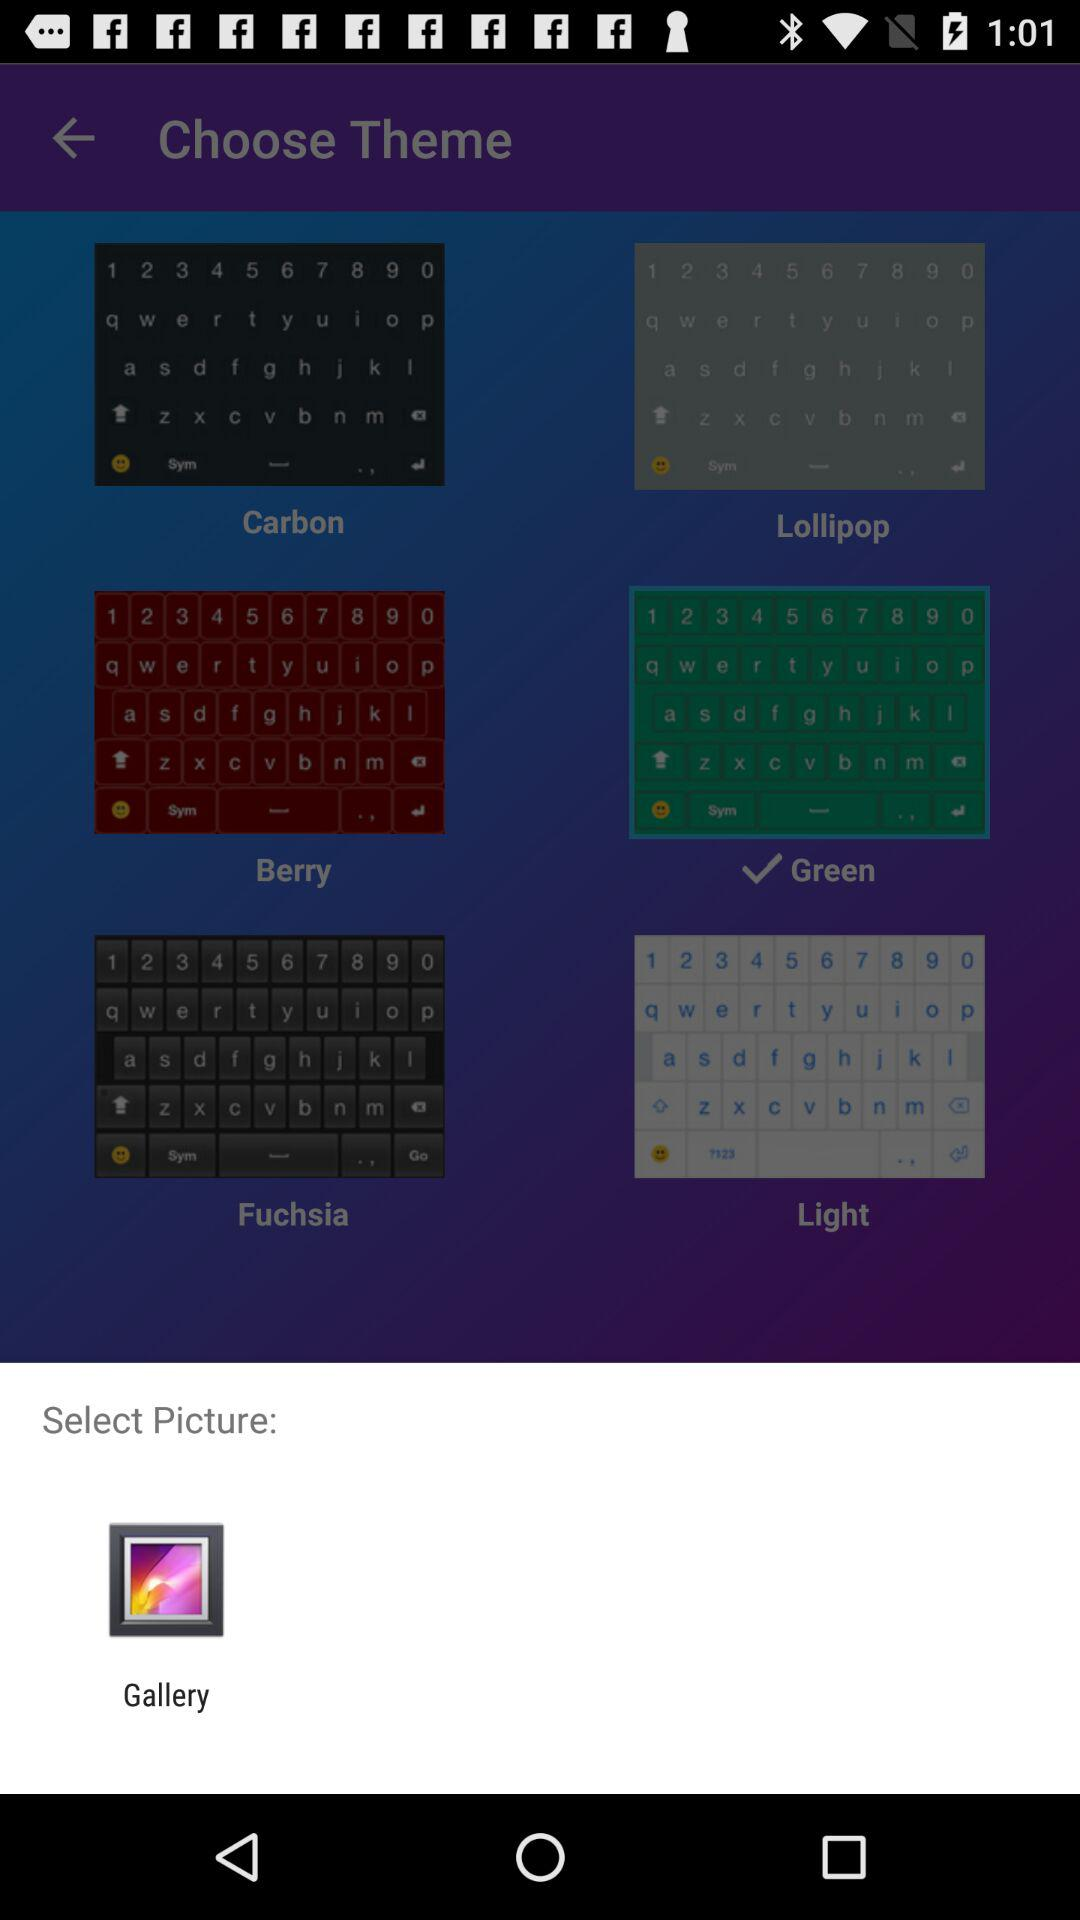How many themes have a checkmark next to them?
Answer the question using a single word or phrase. 1 